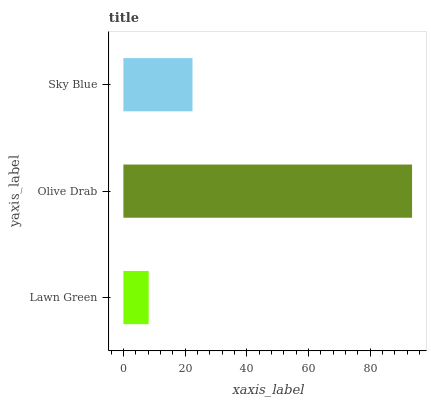Is Lawn Green the minimum?
Answer yes or no. Yes. Is Olive Drab the maximum?
Answer yes or no. Yes. Is Sky Blue the minimum?
Answer yes or no. No. Is Sky Blue the maximum?
Answer yes or no. No. Is Olive Drab greater than Sky Blue?
Answer yes or no. Yes. Is Sky Blue less than Olive Drab?
Answer yes or no. Yes. Is Sky Blue greater than Olive Drab?
Answer yes or no. No. Is Olive Drab less than Sky Blue?
Answer yes or no. No. Is Sky Blue the high median?
Answer yes or no. Yes. Is Sky Blue the low median?
Answer yes or no. Yes. Is Olive Drab the high median?
Answer yes or no. No. Is Olive Drab the low median?
Answer yes or no. No. 